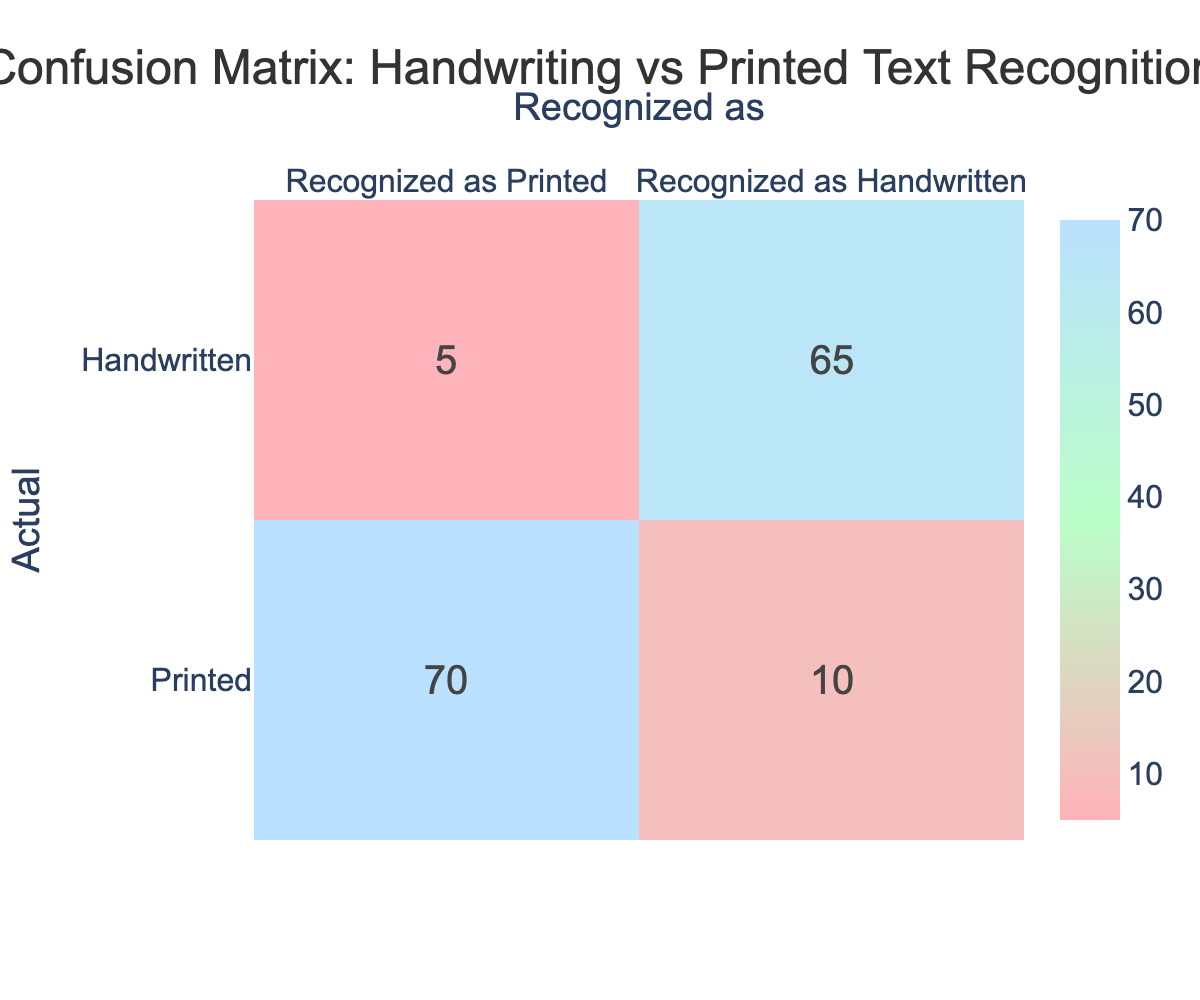What is the total number of printed notes recognized accurately? The accurate recognition of printed notes is the sum of the values in the "Recognized as Printed" column for the "Printed" row. This value is 70.
Answer: 70 How many handwritten notes were incorrectly recognized as printed? The number of handwritten notes incorrectly recognized as printed is found in the "Recognized as Printed" column for the "Handwritten" row, which is 5.
Answer: 5 What is the total number of handwritten notes? The total number of handwritten notes is the sum of those recognized as handwritten and those recognized incorrectly as printed. This is 65 (handwritten recognized) + 5 (handwritten recognized as printed) = 70.
Answer: 70 What percentage of the printed notes were recognized correctly? To find the percentage of printed notes recognized accurately: (70 true positives / (70 true positives + 10 false negatives)) * 100 = (70 / 80) * 100 = 87.5%.
Answer: 87.5% Did the system have more success in recognizing handwritten notes compared to printed notes? To determine this, we compare the correct recognition rates: 65 out of 70 for handwritten (92.9%) and 70 out of 80 for printed (87.5%). Handwritten notes had a higher success rate.
Answer: Yes What is the total number of items assessed for recognition? The total is the sum of all true and false recognitions from both categories: (70 + 10 + 5 + 65 = 150).
Answer: 150 What is the difference in the number of printed notes and handwritten notes recognized accurately? The difference in accurate recognition is 70 (printed) - 65 (handwritten) = 5.
Answer: 5 Is it true that there were no handwritten notes recognized as printed? By checking the "Recognized as Printed" for "Handwritten," we see a value of 5, so it is false that there were no handwritten notes recognized as printed.
Answer: No What is the ratio of printed notes recognized correctly to those recognized incorrectly? The numbers show that 70 printed notes are recognized correctly and 10 incorrectly, so the ratio is 70:10 which simplifies to 7:1.
Answer: 7:1 What is the overall accuracy of the handwriting recognition system? Overall accuracy is calculated as the sum of true positives divided by the total number of items: (70 printed + 65 handwritten) / 150 total = 0.9 or 90%.
Answer: 90% 